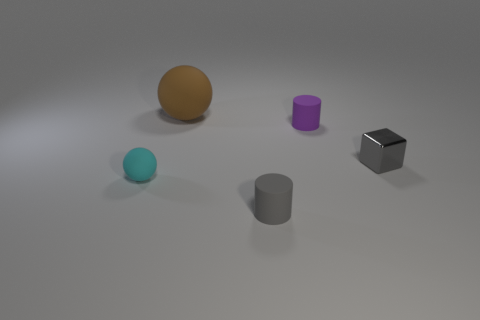Is there any other thing that has the same size as the brown sphere?
Offer a very short reply. No. Is there any other thing that is made of the same material as the cube?
Ensure brevity in your answer.  No. How many other things are there of the same color as the big ball?
Provide a short and direct response. 0. The tiny thing left of the large brown rubber object has what shape?
Offer a terse response. Sphere. Do the tiny cyan object and the tiny gray block have the same material?
Offer a terse response. No. How many rubber spheres are to the left of the big ball?
Provide a succinct answer. 1. There is a gray object that is behind the small cylinder that is in front of the tiny shiny thing; what shape is it?
Keep it short and to the point. Cube. Are there any other things that have the same shape as the cyan thing?
Keep it short and to the point. Yes. Is the number of brown spheres that are left of the small gray metallic thing greater than the number of cyan objects?
Provide a succinct answer. No. How many purple objects are right of the tiny rubber thing that is behind the cyan sphere?
Make the answer very short. 0. 